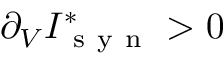<formula> <loc_0><loc_0><loc_500><loc_500>\partial _ { V } I _ { s y n } ^ { * } > 0</formula> 